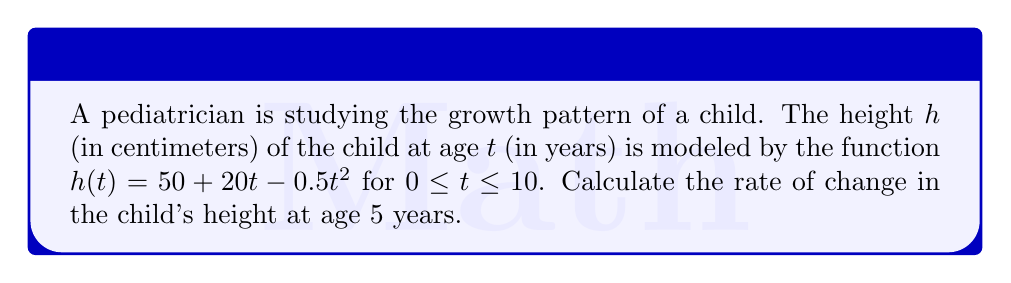Provide a solution to this math problem. To find the rate of change in the child's height at age 5 years, we need to calculate the derivative of the height function $h(t)$ and evaluate it at $t = 5$.

Step 1: Find the derivative of $h(t)$.
$h(t) = 50 + 20t - 0.5t^2$
$h'(t) = 20 - t$

Step 2: Evaluate $h'(t)$ at $t = 5$.
$h'(5) = 20 - 5 = 15$

The rate of change in the child's height at age 5 years is 15 cm/year.

This result indicates that at age 5, the child's height is increasing at a rate of 15 cm per year. As a pediatrician, this information is valuable for assessing whether the child's growth rate is within normal ranges and for providing appropriate guidance to parents regarding their child's development.
Answer: 15 cm/year 